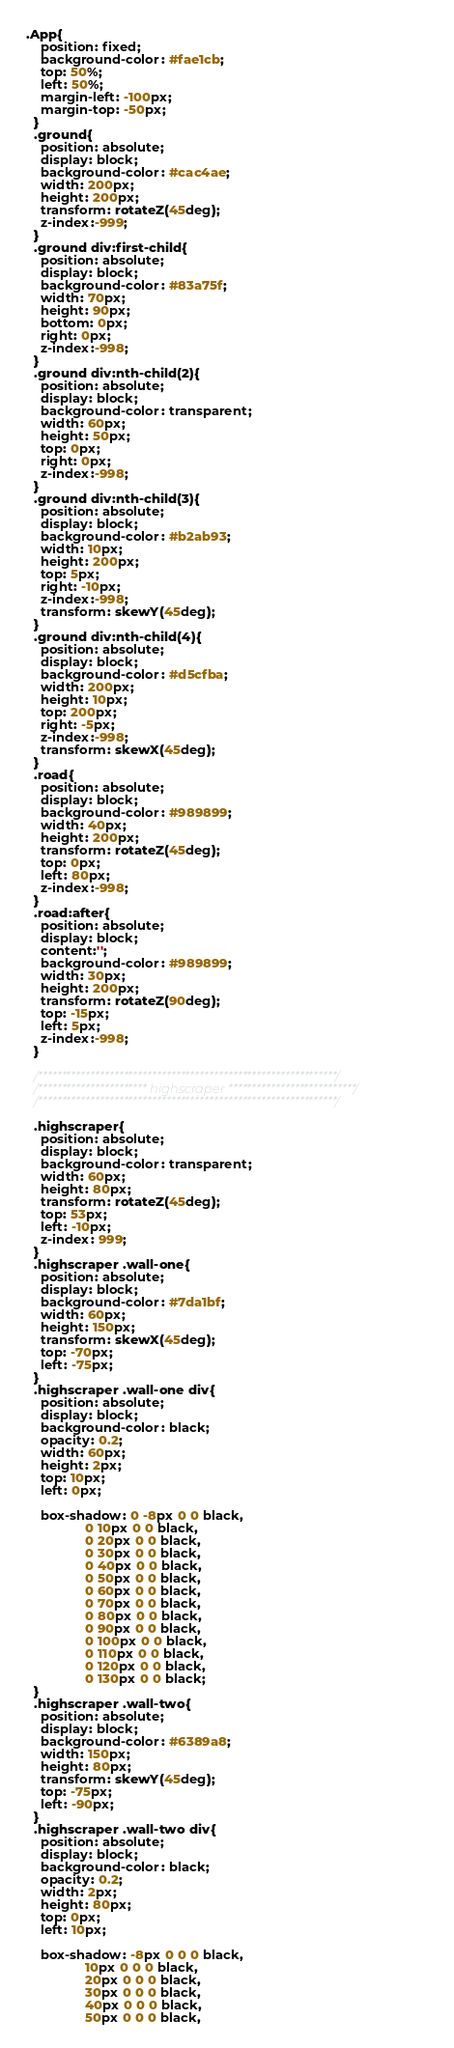Convert code to text. <code><loc_0><loc_0><loc_500><loc_500><_CSS_>.App{
    position: fixed;
    background-color: #fae1cb;
    top: 50%;
    left: 50%;
    margin-left: -100px;
    margin-top: -50px;
  }
  .ground{
    position: absolute;
    display: block;
    background-color: #cac4ae;
    width: 200px;
    height: 200px;
    transform: rotateZ(45deg);
    z-index:-999;
  }
  .ground div:first-child{
    position: absolute;
    display: block;
    background-color: #83a75f;
    width: 70px;
    height: 90px;
    bottom: 0px;
    right: 0px;
    z-index:-998;
  }
  .ground div:nth-child(2){
    position: absolute;
    display: block;
    background-color: transparent;
    width: 60px;
    height: 50px;
    top: 0px;
    right: 0px;
    z-index:-998;
  }
  .ground div:nth-child(3){
    position: absolute;
    display: block;
    background-color: #b2ab93;
    width: 10px;
    height: 200px;
    top: 5px;
    right: -10px;
    z-index:-998;
    transform: skewY(45deg);
  }
  .ground div:nth-child(4){
    position: absolute;
    display: block;
    background-color: #d5cfba;
    width: 200px;
    height: 10px;
    top: 200px;
    right: -5px;
    z-index:-998;
    transform: skewX(45deg);
  }
  .road{
    position: absolute;
    display: block;
    background-color: #989899;
    width: 40px;
    height: 200px;
    transform: rotateZ(45deg);
    top: 0px;
    left: 80px;
    z-index:-998;
  }
  .road:after{
    position: absolute;
    display: block;
    content:'';
    background-color: #989899;
    width: 30px;
    height: 200px;
    transform: rotateZ(90deg);
    top: -15px;
    left: 5px;
    z-index:-998;
  }
  
  /***************************************************************/
  /*********************** highscraper ***************************/
  /***************************************************************/
  
  .highscraper{
    position: absolute;
    display: block;
    background-color: transparent;
    width: 60px;
    height: 80px;
    transform: rotateZ(45deg);
    top: 53px;
    left: -10px;
    z-index: 999;
  }
  .highscraper .wall-one{
    position: absolute;
    display: block;
    background-color: #7da1bf;
    width: 60px;
    height: 150px;
    transform: skewX(45deg);
    top: -70px;
    left: -75px;
  }
  .highscraper .wall-one div{
    position: absolute;
    display: block;
    background-color: black;
    opacity: 0.2;
    width: 60px;
    height: 2px;
    top: 10px;
    left: 0px;
    
    box-shadow: 0 -8px 0 0 black,
                0 10px 0 0 black,
                0 20px 0 0 black,
                0 30px 0 0 black,
                0 40px 0 0 black,
                0 50px 0 0 black,
                0 60px 0 0 black,
                0 70px 0 0 black,
                0 80px 0 0 black,
                0 90px 0 0 black,
                0 100px 0 0 black,
                0 110px 0 0 black,
                0 120px 0 0 black,
                0 130px 0 0 black;
  }
  .highscraper .wall-two{
    position: absolute;
    display: block;
    background-color: #6389a8;
    width: 150px;
    height: 80px;
    transform: skewY(45deg);
    top: -75px;
    left: -90px;
  }
  .highscraper .wall-two div{
    position: absolute;
    display: block;
    background-color: black;
    opacity: 0.2;
    width: 2px;
    height: 80px;
    top: 0px;
    left: 10px;
    
    box-shadow: -8px 0 0 0 black,
                10px 0 0 0 black,
                20px 0 0 0 black,
                30px 0 0 0 black,
                40px 0 0 0 black,
                50px 0 0 0 black,</code> 